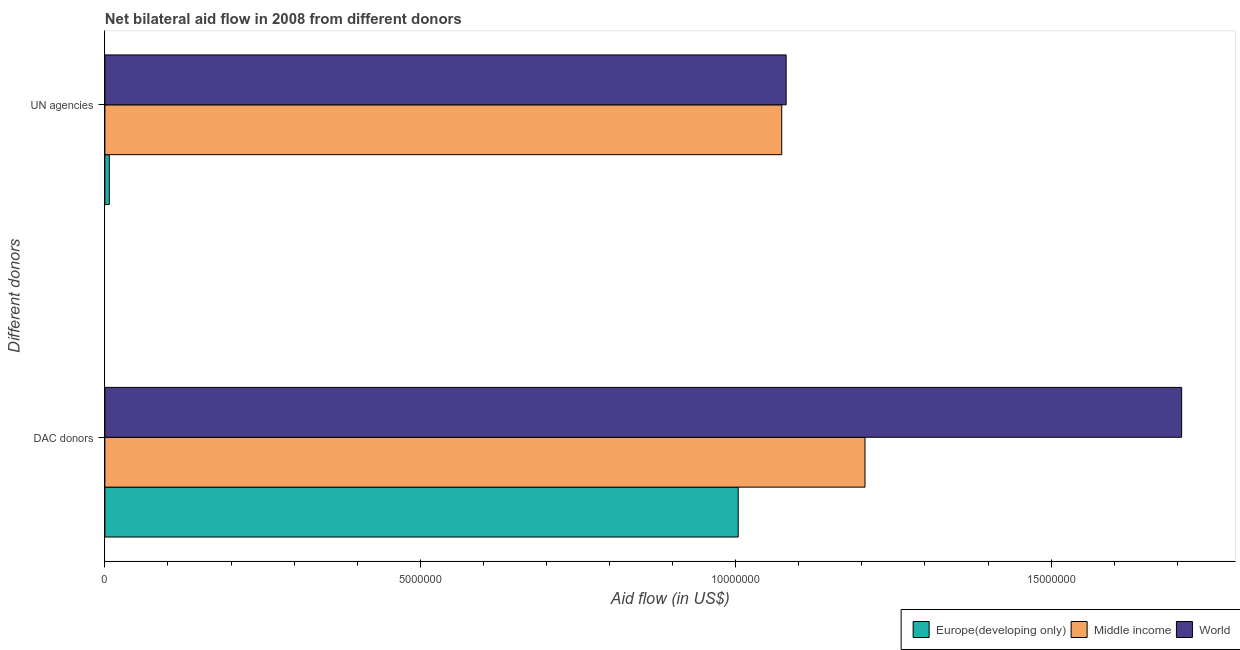Are the number of bars on each tick of the Y-axis equal?
Provide a short and direct response. Yes. How many bars are there on the 2nd tick from the top?
Keep it short and to the point. 3. What is the label of the 1st group of bars from the top?
Provide a succinct answer. UN agencies. What is the aid flow from dac donors in Middle income?
Provide a succinct answer. 1.20e+07. Across all countries, what is the maximum aid flow from dac donors?
Keep it short and to the point. 1.71e+07. Across all countries, what is the minimum aid flow from un agencies?
Keep it short and to the point. 7.00e+04. In which country was the aid flow from dac donors maximum?
Keep it short and to the point. World. In which country was the aid flow from dac donors minimum?
Your answer should be very brief. Europe(developing only). What is the total aid flow from dac donors in the graph?
Offer a very short reply. 3.92e+07. What is the difference between the aid flow from dac donors in Europe(developing only) and that in World?
Provide a succinct answer. -7.03e+06. What is the difference between the aid flow from dac donors in Middle income and the aid flow from un agencies in World?
Give a very brief answer. 1.25e+06. What is the average aid flow from dac donors per country?
Make the answer very short. 1.31e+07. What is the difference between the aid flow from dac donors and aid flow from un agencies in World?
Your answer should be compact. 6.27e+06. What is the ratio of the aid flow from dac donors in Middle income to that in World?
Your answer should be compact. 0.71. What does the 3rd bar from the top in DAC donors represents?
Make the answer very short. Europe(developing only). What does the 1st bar from the bottom in DAC donors represents?
Make the answer very short. Europe(developing only). How many bars are there?
Your response must be concise. 6. How many countries are there in the graph?
Offer a very short reply. 3. What is the difference between two consecutive major ticks on the X-axis?
Ensure brevity in your answer.  5.00e+06. How many legend labels are there?
Your answer should be very brief. 3. What is the title of the graph?
Give a very brief answer. Net bilateral aid flow in 2008 from different donors. What is the label or title of the X-axis?
Offer a terse response. Aid flow (in US$). What is the label or title of the Y-axis?
Give a very brief answer. Different donors. What is the Aid flow (in US$) of Europe(developing only) in DAC donors?
Offer a terse response. 1.00e+07. What is the Aid flow (in US$) in Middle income in DAC donors?
Your answer should be very brief. 1.20e+07. What is the Aid flow (in US$) of World in DAC donors?
Provide a short and direct response. 1.71e+07. What is the Aid flow (in US$) of Middle income in UN agencies?
Keep it short and to the point. 1.07e+07. What is the Aid flow (in US$) in World in UN agencies?
Offer a very short reply. 1.08e+07. Across all Different donors, what is the maximum Aid flow (in US$) in Europe(developing only)?
Offer a very short reply. 1.00e+07. Across all Different donors, what is the maximum Aid flow (in US$) in Middle income?
Your answer should be very brief. 1.20e+07. Across all Different donors, what is the maximum Aid flow (in US$) of World?
Provide a short and direct response. 1.71e+07. Across all Different donors, what is the minimum Aid flow (in US$) in Middle income?
Your answer should be compact. 1.07e+07. Across all Different donors, what is the minimum Aid flow (in US$) of World?
Your response must be concise. 1.08e+07. What is the total Aid flow (in US$) in Europe(developing only) in the graph?
Keep it short and to the point. 1.01e+07. What is the total Aid flow (in US$) in Middle income in the graph?
Give a very brief answer. 2.28e+07. What is the total Aid flow (in US$) of World in the graph?
Offer a terse response. 2.79e+07. What is the difference between the Aid flow (in US$) of Europe(developing only) in DAC donors and that in UN agencies?
Make the answer very short. 9.97e+06. What is the difference between the Aid flow (in US$) in Middle income in DAC donors and that in UN agencies?
Offer a very short reply. 1.32e+06. What is the difference between the Aid flow (in US$) in World in DAC donors and that in UN agencies?
Your response must be concise. 6.27e+06. What is the difference between the Aid flow (in US$) in Europe(developing only) in DAC donors and the Aid flow (in US$) in Middle income in UN agencies?
Provide a short and direct response. -6.90e+05. What is the difference between the Aid flow (in US$) in Europe(developing only) in DAC donors and the Aid flow (in US$) in World in UN agencies?
Your answer should be compact. -7.60e+05. What is the difference between the Aid flow (in US$) in Middle income in DAC donors and the Aid flow (in US$) in World in UN agencies?
Make the answer very short. 1.25e+06. What is the average Aid flow (in US$) in Europe(developing only) per Different donors?
Provide a succinct answer. 5.06e+06. What is the average Aid flow (in US$) in Middle income per Different donors?
Provide a succinct answer. 1.14e+07. What is the average Aid flow (in US$) of World per Different donors?
Your answer should be very brief. 1.39e+07. What is the difference between the Aid flow (in US$) of Europe(developing only) and Aid flow (in US$) of Middle income in DAC donors?
Provide a succinct answer. -2.01e+06. What is the difference between the Aid flow (in US$) in Europe(developing only) and Aid flow (in US$) in World in DAC donors?
Offer a terse response. -7.03e+06. What is the difference between the Aid flow (in US$) of Middle income and Aid flow (in US$) of World in DAC donors?
Offer a terse response. -5.02e+06. What is the difference between the Aid flow (in US$) of Europe(developing only) and Aid flow (in US$) of Middle income in UN agencies?
Offer a very short reply. -1.07e+07. What is the difference between the Aid flow (in US$) in Europe(developing only) and Aid flow (in US$) in World in UN agencies?
Offer a very short reply. -1.07e+07. What is the difference between the Aid flow (in US$) of Middle income and Aid flow (in US$) of World in UN agencies?
Make the answer very short. -7.00e+04. What is the ratio of the Aid flow (in US$) in Europe(developing only) in DAC donors to that in UN agencies?
Keep it short and to the point. 143.43. What is the ratio of the Aid flow (in US$) in Middle income in DAC donors to that in UN agencies?
Provide a short and direct response. 1.12. What is the ratio of the Aid flow (in US$) in World in DAC donors to that in UN agencies?
Make the answer very short. 1.58. What is the difference between the highest and the second highest Aid flow (in US$) of Europe(developing only)?
Offer a terse response. 9.97e+06. What is the difference between the highest and the second highest Aid flow (in US$) in Middle income?
Your answer should be very brief. 1.32e+06. What is the difference between the highest and the second highest Aid flow (in US$) in World?
Your answer should be compact. 6.27e+06. What is the difference between the highest and the lowest Aid flow (in US$) of Europe(developing only)?
Provide a succinct answer. 9.97e+06. What is the difference between the highest and the lowest Aid flow (in US$) of Middle income?
Provide a short and direct response. 1.32e+06. What is the difference between the highest and the lowest Aid flow (in US$) of World?
Offer a very short reply. 6.27e+06. 